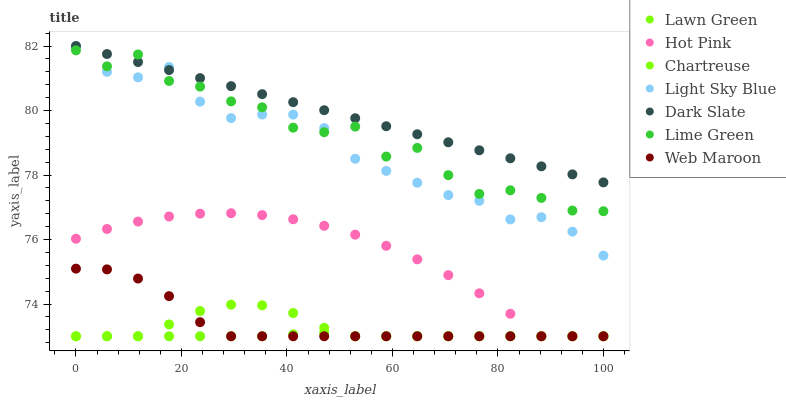Does Lawn Green have the minimum area under the curve?
Answer yes or no. Yes. Does Dark Slate have the maximum area under the curve?
Answer yes or no. Yes. Does Hot Pink have the minimum area under the curve?
Answer yes or no. No. Does Hot Pink have the maximum area under the curve?
Answer yes or no. No. Is Dark Slate the smoothest?
Answer yes or no. Yes. Is Lime Green the roughest?
Answer yes or no. Yes. Is Hot Pink the smoothest?
Answer yes or no. No. Is Hot Pink the roughest?
Answer yes or no. No. Does Lawn Green have the lowest value?
Answer yes or no. Yes. Does Dark Slate have the lowest value?
Answer yes or no. No. Does Light Sky Blue have the highest value?
Answer yes or no. Yes. Does Hot Pink have the highest value?
Answer yes or no. No. Is Hot Pink less than Dark Slate?
Answer yes or no. Yes. Is Lime Green greater than Web Maroon?
Answer yes or no. Yes. Does Web Maroon intersect Chartreuse?
Answer yes or no. Yes. Is Web Maroon less than Chartreuse?
Answer yes or no. No. Is Web Maroon greater than Chartreuse?
Answer yes or no. No. Does Hot Pink intersect Dark Slate?
Answer yes or no. No. 